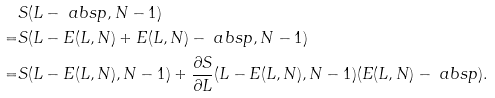<formula> <loc_0><loc_0><loc_500><loc_500>& S ( L - \ a b s { p } , N - 1 ) \\ = & S ( L - E ( L , N ) + E ( L , N ) - \ a b s { p } , N - 1 ) \\ = & S ( L - E ( L , N ) , N - 1 ) + \frac { \partial S } { \partial L } ( L - E ( L , N ) , N - 1 ) ( E ( L , N ) - \ a b s { p } ) .</formula> 